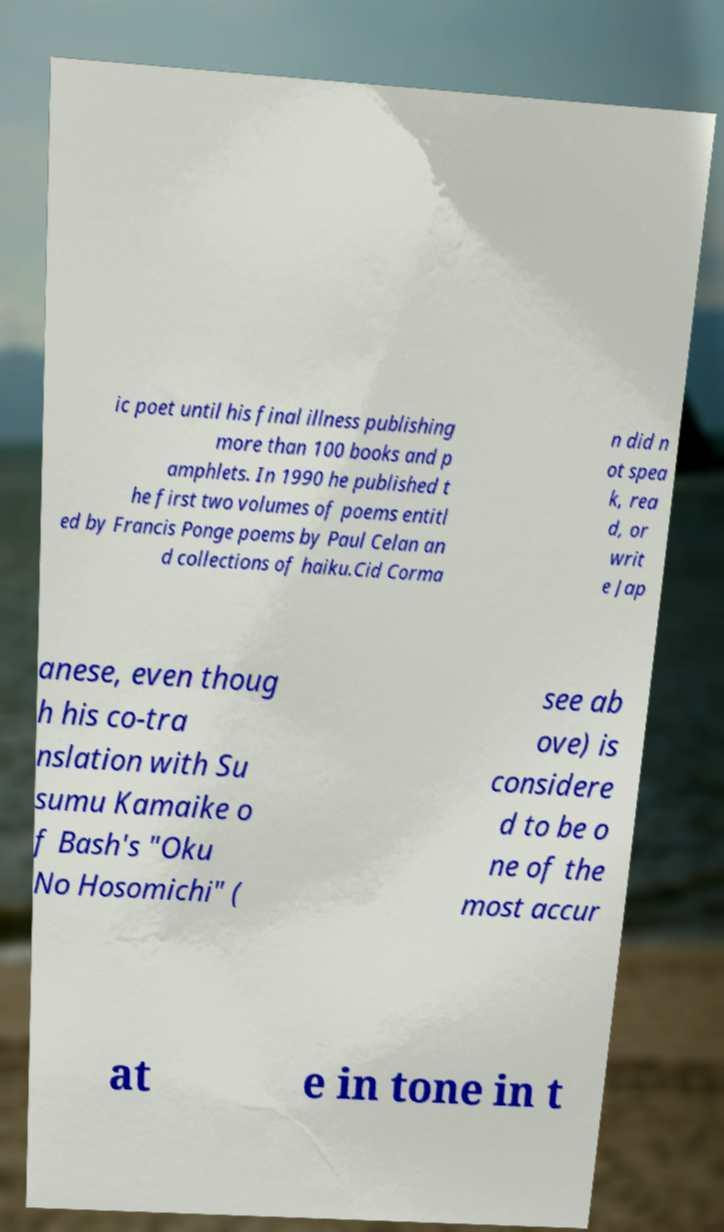Please identify and transcribe the text found in this image. ic poet until his final illness publishing more than 100 books and p amphlets. In 1990 he published t he first two volumes of poems entitl ed by Francis Ponge poems by Paul Celan an d collections of haiku.Cid Corma n did n ot spea k, rea d, or writ e Jap anese, even thoug h his co-tra nslation with Su sumu Kamaike o f Bash's "Oku No Hosomichi" ( see ab ove) is considere d to be o ne of the most accur at e in tone in t 